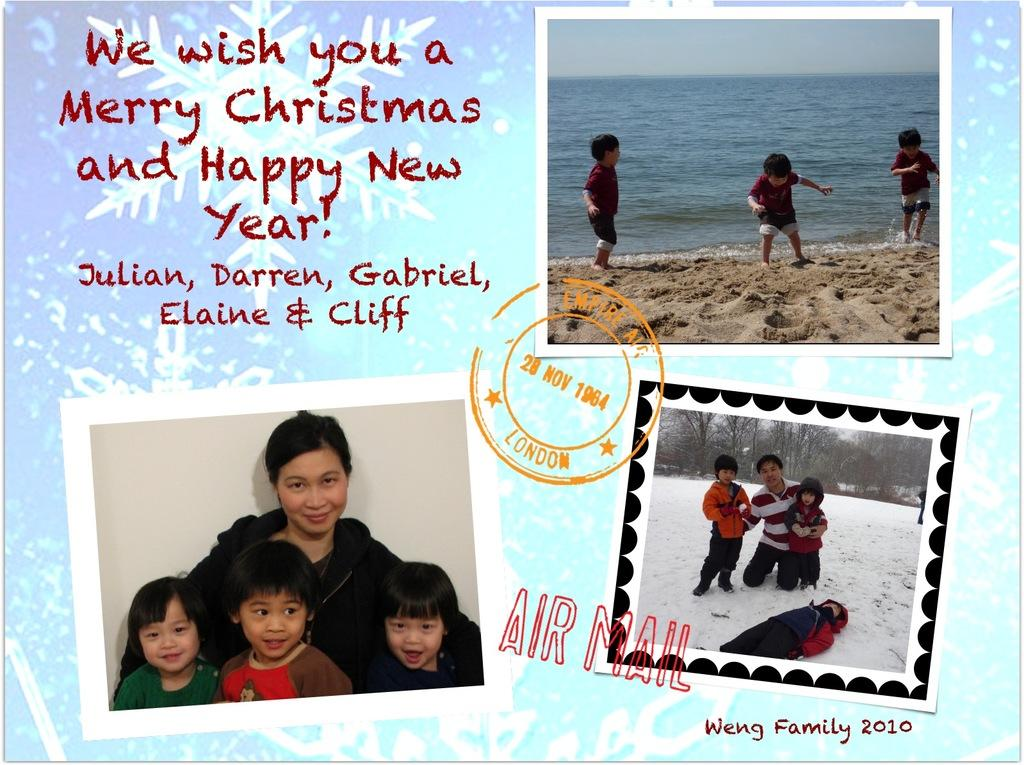What type of visual is the image? The image is a poster. How many pictures are on the poster? There are three pictures on the poster. What else is featured on the poster besides the pictures? There is text on the poster. What can be seen in the pictures on the poster? In the pictures, there is a group of people, water, sand, snow, and trees. Can you see any ghosts in the pictures on the poster? No, there are no ghosts present in the pictures on the poster. What impulse might the group of people in the pictures have? The provided facts do not give any information about the impulses or motivations of the group of people in the pictures, so it cannot be determined from the image. 